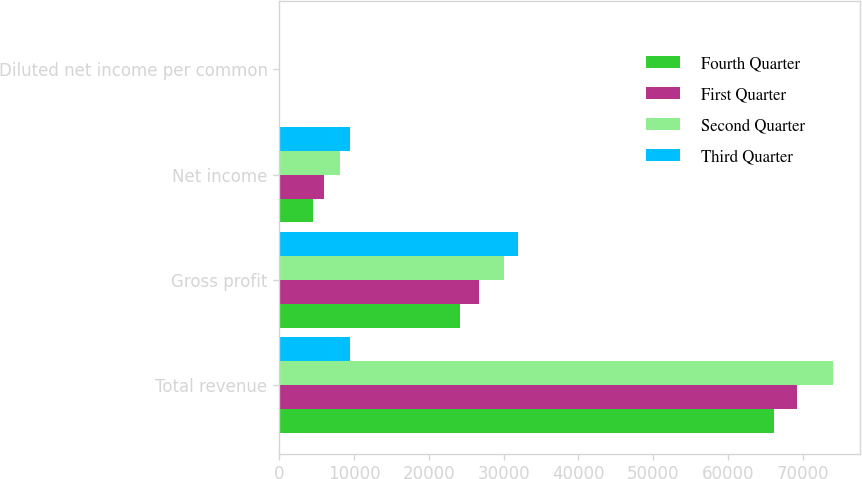Convert chart to OTSL. <chart><loc_0><loc_0><loc_500><loc_500><stacked_bar_chart><ecel><fcel>Total revenue<fcel>Gross profit<fcel>Net income<fcel>Diluted net income per common<nl><fcel>Fourth Quarter<fcel>66176<fcel>24208<fcel>4574<fcel>0.11<nl><fcel>First Quarter<fcel>69237<fcel>26773<fcel>6048<fcel>0.13<nl><fcel>Second Quarter<fcel>74053<fcel>30090<fcel>8158<fcel>0.18<nl><fcel>Third Quarter<fcel>9476<fcel>31953<fcel>9476<fcel>0.2<nl></chart> 